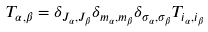<formula> <loc_0><loc_0><loc_500><loc_500>T _ { \alpha , \beta } = \delta _ { J _ { \alpha } , J _ { \beta } } \delta _ { m _ { \alpha } , m _ { \beta } } \delta _ { \sigma _ { \alpha } , \sigma _ { \beta } } T _ { i _ { \alpha } , i _ { \beta } }</formula> 